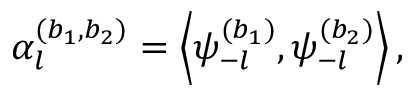Convert formula to latex. <formula><loc_0><loc_0><loc_500><loc_500>\alpha _ { l } ^ { ( b _ { 1 } , b _ { 2 } ) } = \left \langle { \psi _ { - l } ^ { ( b _ { 1 } ) } , \psi _ { - l } ^ { ( b _ { 2 } ) } } \right \rangle ,</formula> 